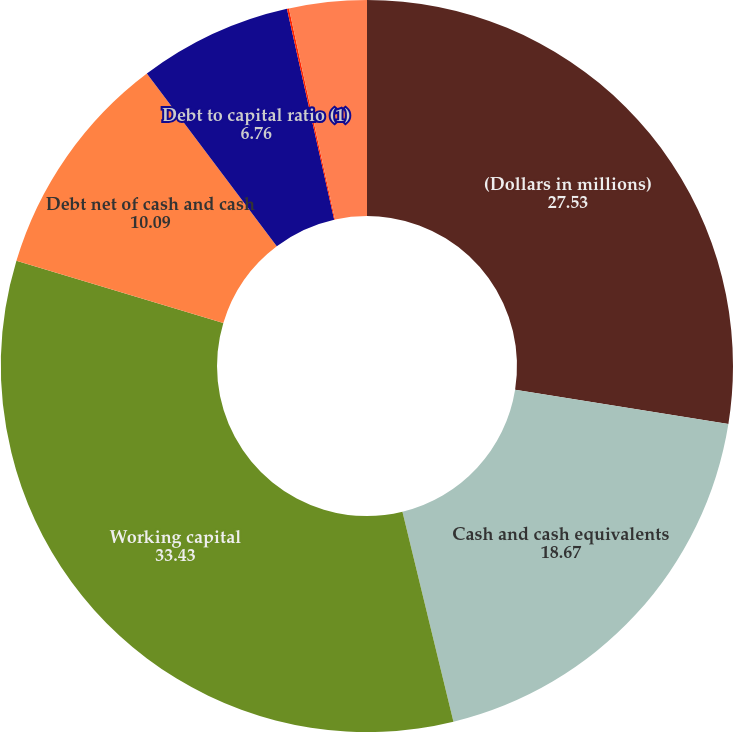Convert chart. <chart><loc_0><loc_0><loc_500><loc_500><pie_chart><fcel>(Dollars in millions)<fcel>Cash and cash equivalents<fcel>Working capital<fcel>Debt net of cash and cash<fcel>Debt to capital ratio (1)<fcel>Net debt to net capital<fcel>Return on stockholders' equity<nl><fcel>27.53%<fcel>18.67%<fcel>33.43%<fcel>10.09%<fcel>6.76%<fcel>0.09%<fcel>3.42%<nl></chart> 